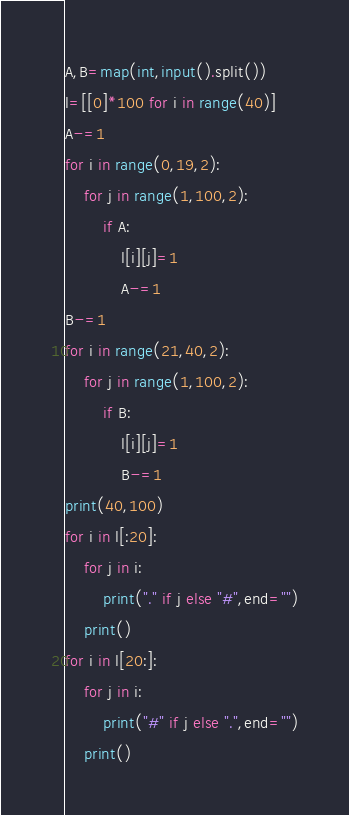<code> <loc_0><loc_0><loc_500><loc_500><_Python_>A,B=map(int,input().split())
l=[[0]*100 for i in range(40)]
A-=1
for i in range(0,19,2):
    for j in range(1,100,2):
        if A:
            l[i][j]=1
            A-=1
B-=1
for i in range(21,40,2):
    for j in range(1,100,2):
        if B:
            l[i][j]=1
            B-=1
print(40,100)
for i in l[:20]:
    for j in i:
        print("." if j else "#",end="")
    print()
for i in l[20:]:
    for j in i:
        print("#" if j else ".",end="")
    print()</code> 